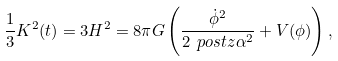<formula> <loc_0><loc_0><loc_500><loc_500>\frac { 1 } { 3 } K ^ { 2 } ( t ) = 3 H ^ { 2 } = 8 \pi G \left ( \frac { \dot { \phi } ^ { 2 } } { 2 \ p o s t z \alpha ^ { 2 } } + V ( \phi ) \right ) ,</formula> 